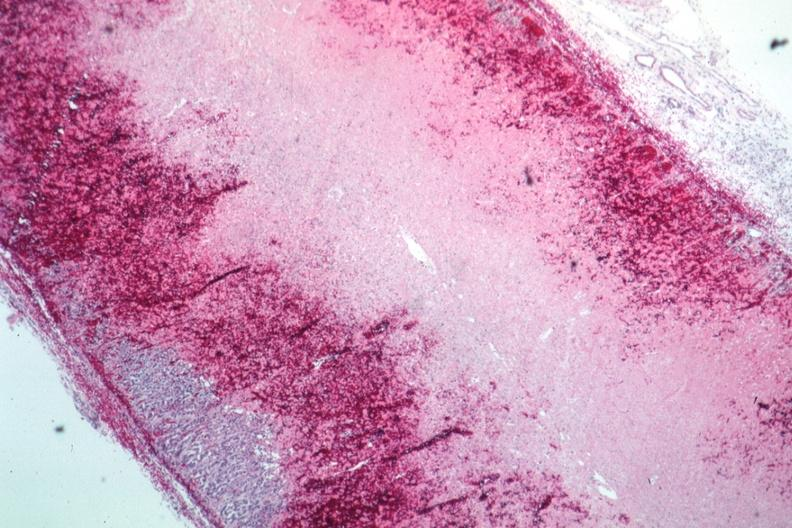s this typical lesion present?
Answer the question using a single word or phrase. No 